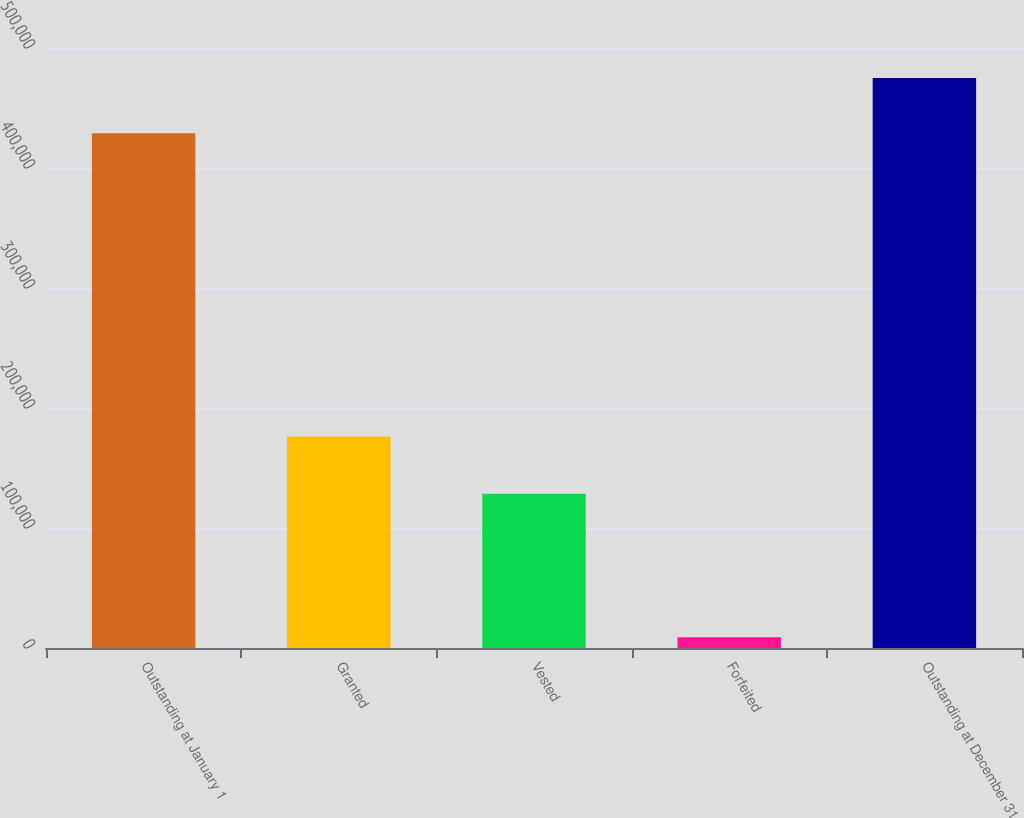<chart> <loc_0><loc_0><loc_500><loc_500><bar_chart><fcel>Outstanding at January 1<fcel>Granted<fcel>Vested<fcel>Forfeited<fcel>Outstanding at December 31<nl><fcel>429041<fcel>176159<fcel>128549<fcel>8906<fcel>474925<nl></chart> 